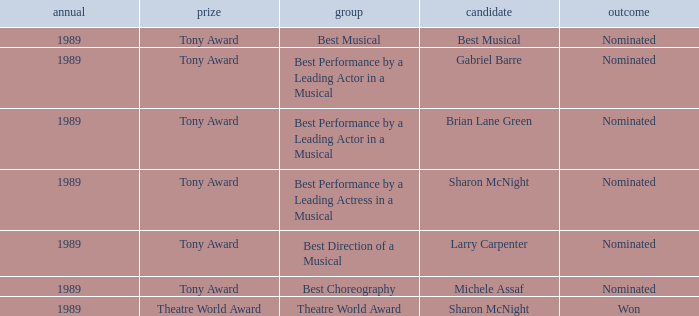What was the nominee of best musical Best Musical. 